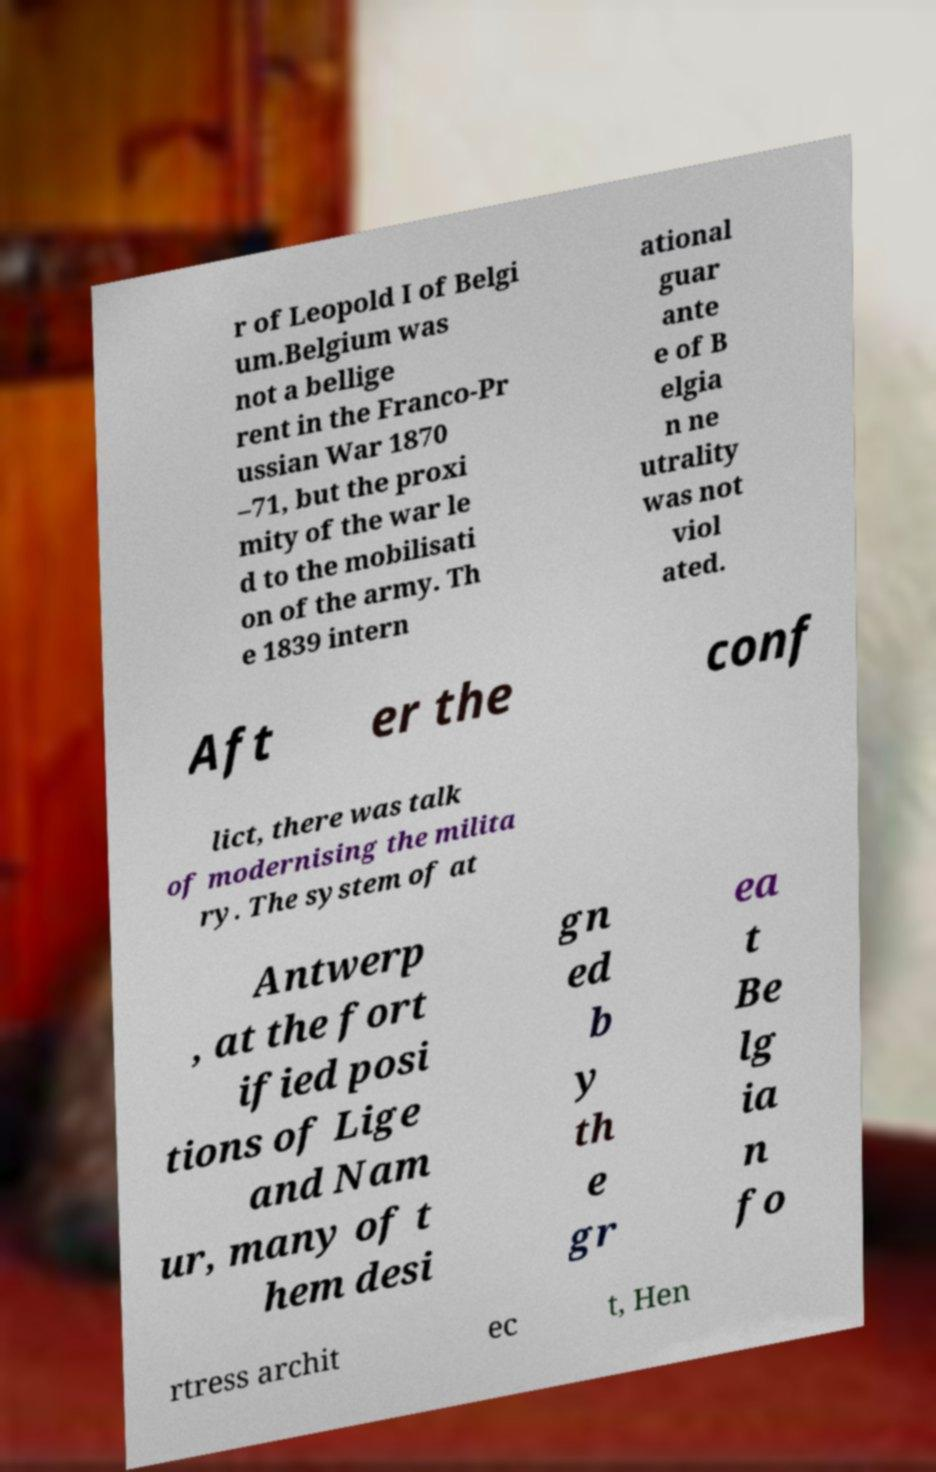For documentation purposes, I need the text within this image transcribed. Could you provide that? r of Leopold I of Belgi um.Belgium was not a bellige rent in the Franco-Pr ussian War 1870 –71, but the proxi mity of the war le d to the mobilisati on of the army. Th e 1839 intern ational guar ante e of B elgia n ne utrality was not viol ated. Aft er the conf lict, there was talk of modernising the milita ry. The system of at Antwerp , at the fort ified posi tions of Lige and Nam ur, many of t hem desi gn ed b y th e gr ea t Be lg ia n fo rtress archit ec t, Hen 